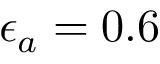Convert formula to latex. <formula><loc_0><loc_0><loc_500><loc_500>\epsilon _ { a } = 0 . 6</formula> 